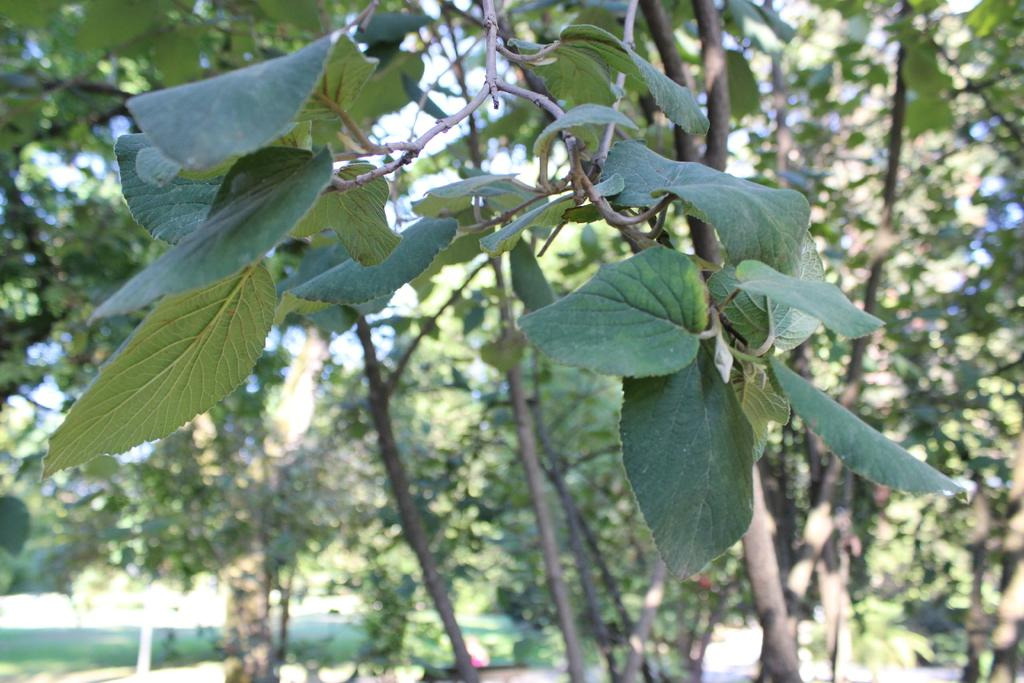What type of vegetation can be seen in the image? There are trees in the image. How is the background of the image? The background of the image is blurry. What type of hammer is being used to cut the flesh in the image? There is no hammer or flesh present in the image; it only features trees and a blurry background. 